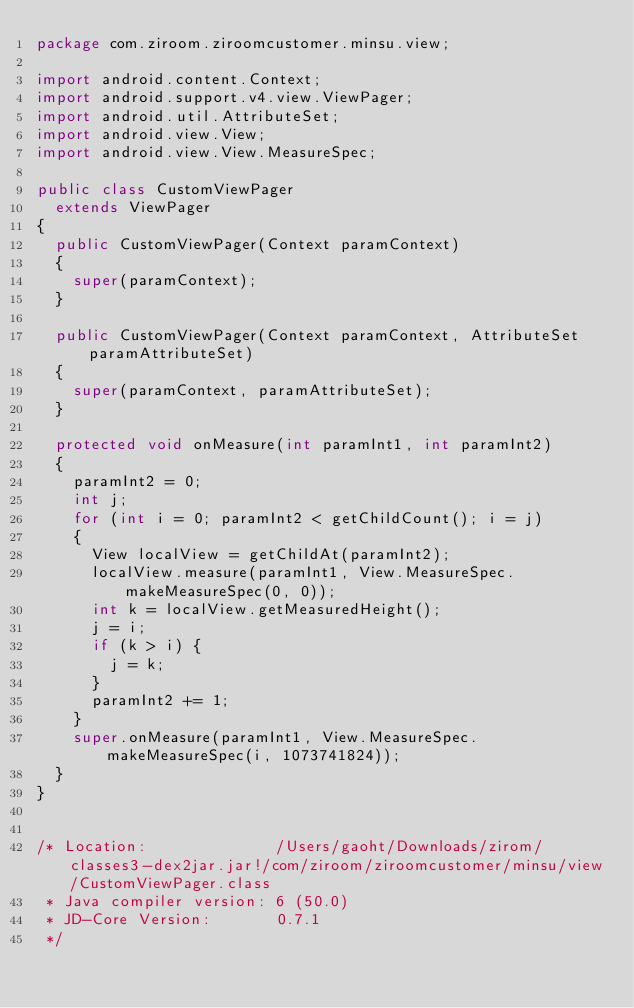<code> <loc_0><loc_0><loc_500><loc_500><_Java_>package com.ziroom.ziroomcustomer.minsu.view;

import android.content.Context;
import android.support.v4.view.ViewPager;
import android.util.AttributeSet;
import android.view.View;
import android.view.View.MeasureSpec;

public class CustomViewPager
  extends ViewPager
{
  public CustomViewPager(Context paramContext)
  {
    super(paramContext);
  }
  
  public CustomViewPager(Context paramContext, AttributeSet paramAttributeSet)
  {
    super(paramContext, paramAttributeSet);
  }
  
  protected void onMeasure(int paramInt1, int paramInt2)
  {
    paramInt2 = 0;
    int j;
    for (int i = 0; paramInt2 < getChildCount(); i = j)
    {
      View localView = getChildAt(paramInt2);
      localView.measure(paramInt1, View.MeasureSpec.makeMeasureSpec(0, 0));
      int k = localView.getMeasuredHeight();
      j = i;
      if (k > i) {
        j = k;
      }
      paramInt2 += 1;
    }
    super.onMeasure(paramInt1, View.MeasureSpec.makeMeasureSpec(i, 1073741824));
  }
}


/* Location:              /Users/gaoht/Downloads/zirom/classes3-dex2jar.jar!/com/ziroom/ziroomcustomer/minsu/view/CustomViewPager.class
 * Java compiler version: 6 (50.0)
 * JD-Core Version:       0.7.1
 */</code> 